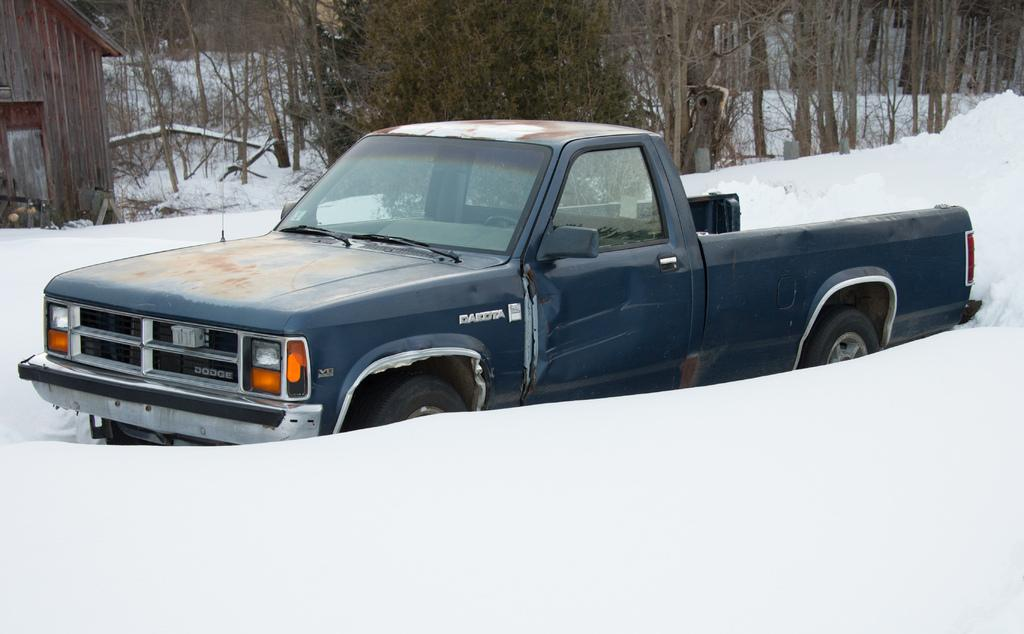What type of vehicle is in the image? The facts do not specify the type of vehicle, but it is present in the image. What is the surface the vehicle is on? The vehicle is on a snow surface. What type of building can be seen in the image? There is a wooden house visible in the image. How much of the wooden house is visible? The wooden house is partially shown. What type of vegetation is present in the image? There are trees in the image. How many chickens are on the roof of the wooden house in the image? There are no chickens present in the image. What type of adjustment is being made to the vehicle in the image? There is no indication of any adjustments being made to the vehicle in the image. 